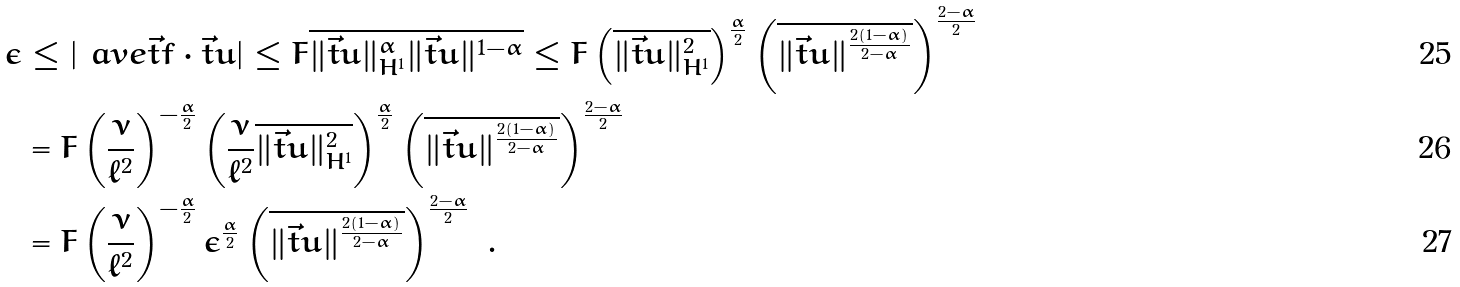<formula> <loc_0><loc_0><loc_500><loc_500>\epsilon & \leq | \ a v e { \vec { t } f \cdot \vec { t } u } | \leq F \overline { \| \vec { t } u \| _ { H ^ { 1 } } ^ { \alpha } \| \vec { t } u \| ^ { 1 - \alpha } } \leq F \left ( \overline { \| \vec { t } u \| _ { H ^ { 1 } } ^ { 2 } } \right ) ^ { \frac { \alpha } { 2 } } \left ( \overline { \| \vec { t } u \| ^ { \frac { 2 ( 1 - \alpha ) } { 2 - \alpha } } } \right ) ^ { \frac { 2 - \alpha } { 2 } } \\ & = F \left ( \frac { \nu } { \ell ^ { 2 } } \right ) ^ { - \frac { \alpha } { 2 } } \left ( \frac { \nu } { \ell ^ { 2 } } \overline { \| \vec { t } u \| _ { H ^ { 1 } } ^ { 2 } } \right ) ^ { \frac { \alpha } { 2 } } \left ( \overline { \| \vec { t } u \| ^ { \frac { 2 ( 1 - \alpha ) } { 2 - \alpha } } } \right ) ^ { \frac { 2 - \alpha } { 2 } } \\ & = F \left ( \frac { \nu } { \ell ^ { 2 } } \right ) ^ { - \frac { \alpha } { 2 } } \epsilon ^ { \frac { \alpha } { 2 } } \left ( \overline { \| \vec { t } u \| ^ { \frac { 2 ( 1 - \alpha ) } { 2 - \alpha } } } \right ) ^ { \frac { 2 - \alpha } { 2 } } \ .</formula> 